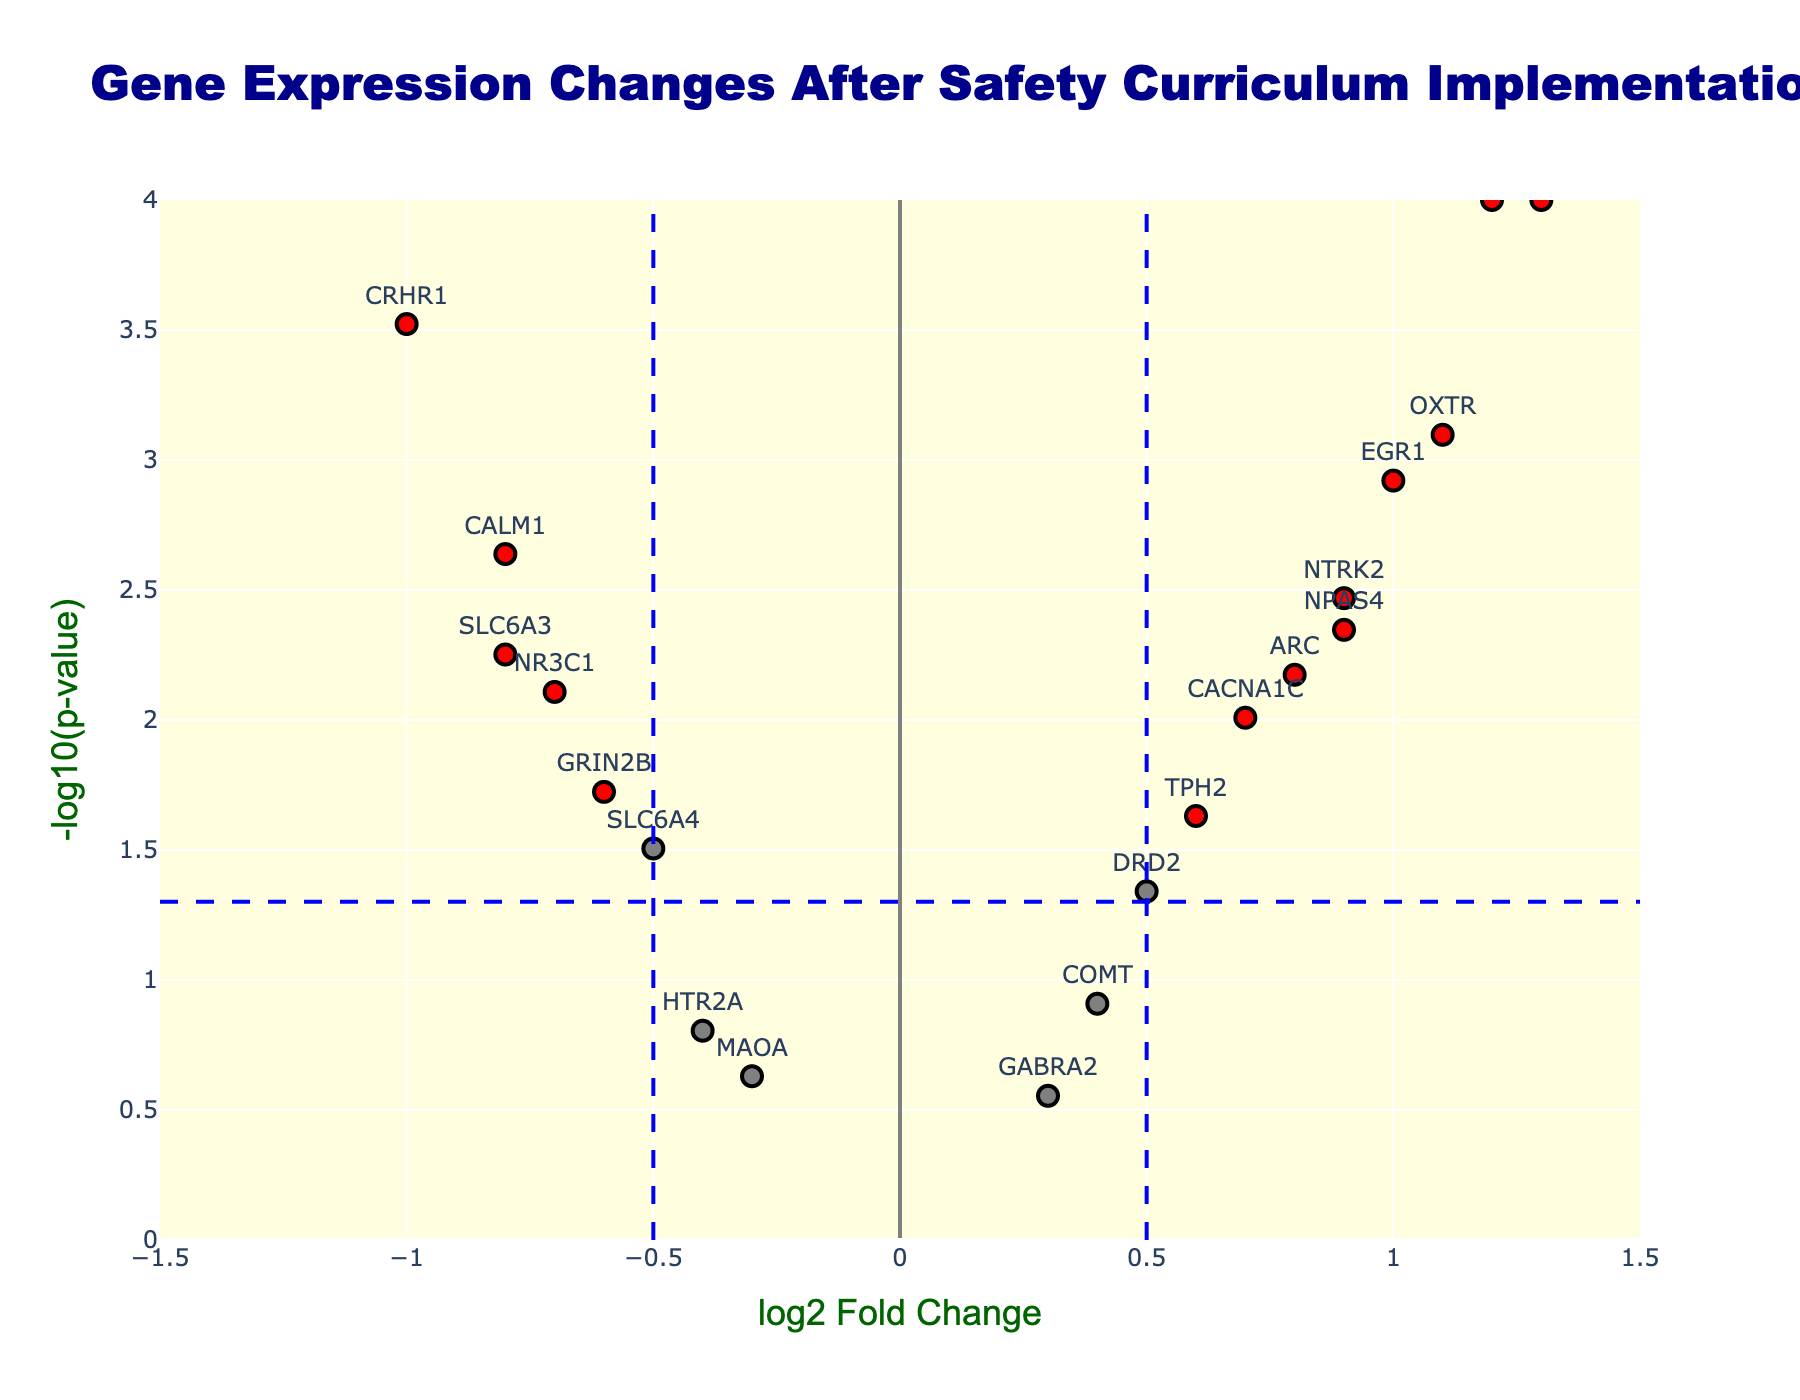What's the title of the figure? The title is located at the top of the figure in bold text.
Answer: Gene Expression Changes After Safety Curriculum Implementation Which gene has the highest log2 fold change? Locate the data point on the x-axis with the highest positive value. Check the corresponding gene label.
Answer: FOS How many genes have a p-value less than 0.01? Identify the data points on the y-axis above the -log10(p-value) threshold of 2. Count these points.
Answer: 7 Which genes have a log2 fold change less than -0.5 and a p-value lower than 0.05? Look for data points to the left of -0.5 (on the x-axis) and higher than the threshold line corresponding to 0.05 (on the y-axis). Check their labels.
Answer: CALM1, CRHR1, SLC6A3, NR3C1, GRIN2B What is the range of the x-axis in this plot? The x-axis range is shown at the bottom of the figure, from the leftmost to the rightmost position of the scale.
Answer: -1.5 to 1.5 Which data points fall at the intersection of the fold change and p-value thresholds? Locate points at x = ±0.5 and y = 1.301 (log10(0.05)). Identify these intersections and check for nearby data points.
Answer: None How many genes show a positive log2 fold change greater than 0.7? Identify data points to the right of 0.7 on the x-axis and count these points.
Answer: 6 Which gene has the lowest p-value? Identify the highest point on the y-axis (since y = -log10(p-value)) and check the corresponding gene label.
Answer: BDNF and FOS What is the range of the y-axis for -log10(p-value)? The y-axis range is shown at the left side of the figure, from the bottom to the top of the scale.
Answer: 0 to 4 